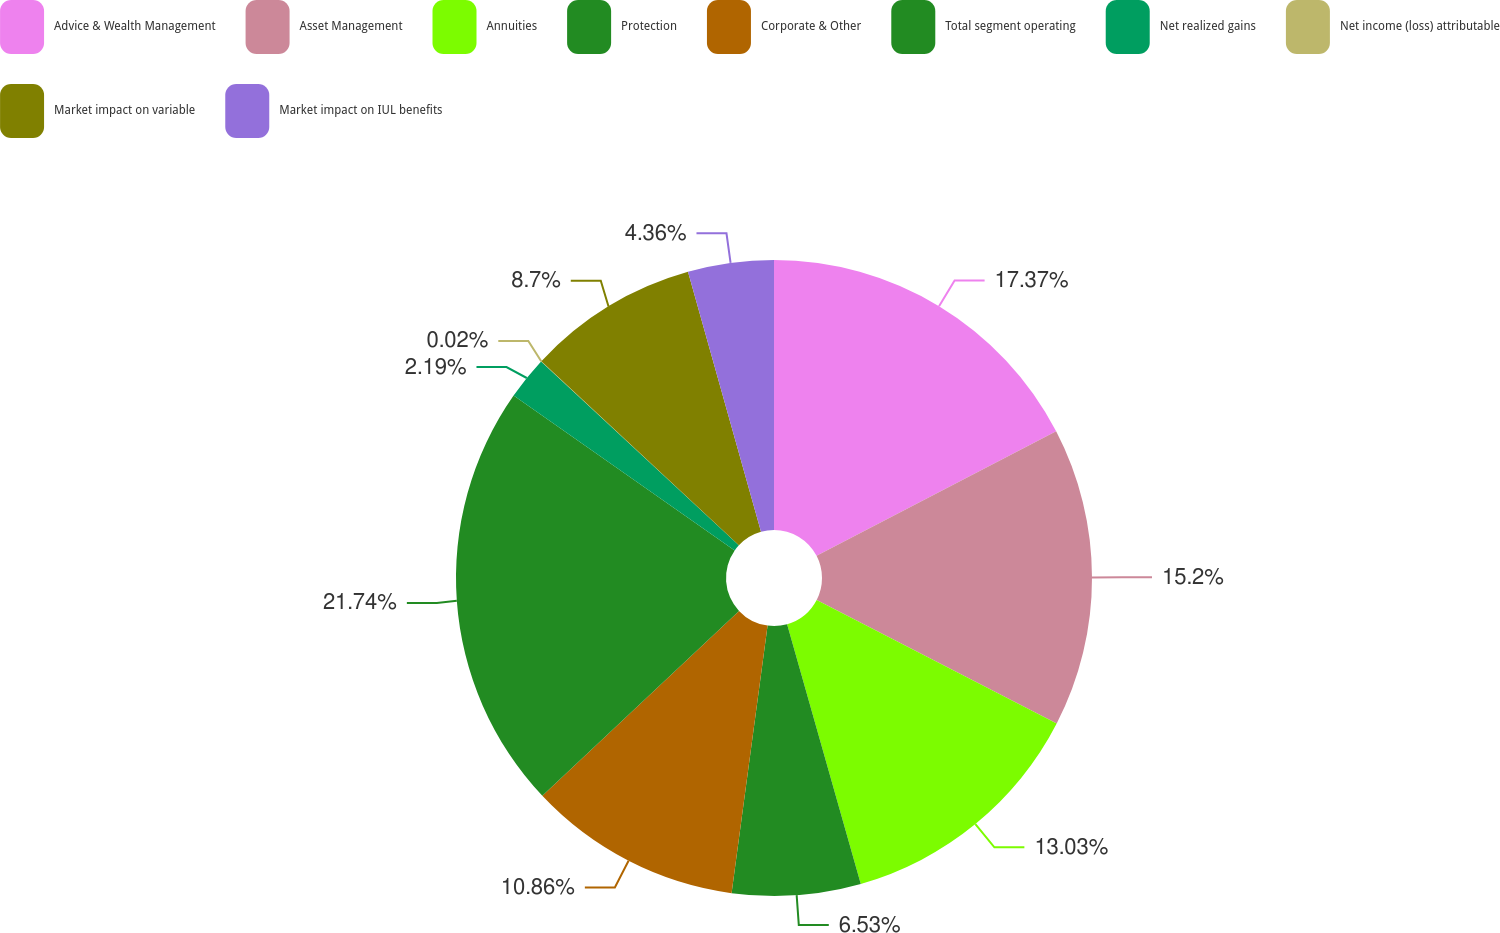<chart> <loc_0><loc_0><loc_500><loc_500><pie_chart><fcel>Advice & Wealth Management<fcel>Asset Management<fcel>Annuities<fcel>Protection<fcel>Corporate & Other<fcel>Total segment operating<fcel>Net realized gains<fcel>Net income (loss) attributable<fcel>Market impact on variable<fcel>Market impact on IUL benefits<nl><fcel>17.37%<fcel>15.2%<fcel>13.03%<fcel>6.53%<fcel>10.86%<fcel>21.74%<fcel>2.19%<fcel>0.02%<fcel>8.7%<fcel>4.36%<nl></chart> 